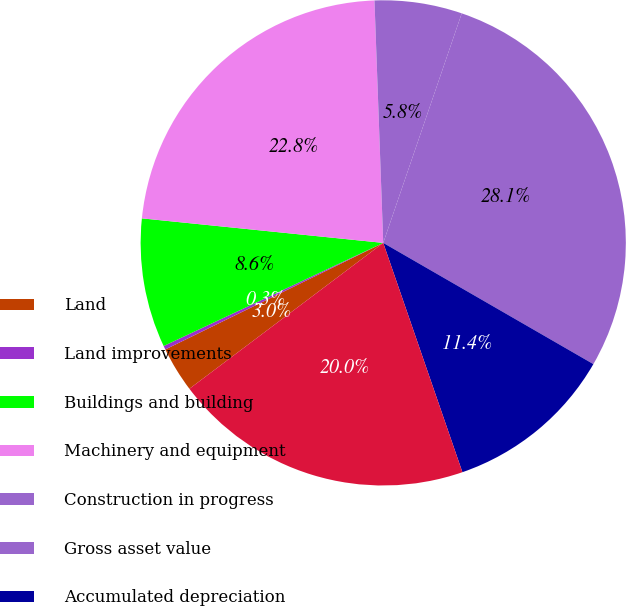Convert chart. <chart><loc_0><loc_0><loc_500><loc_500><pie_chart><fcel>Land<fcel>Land improvements<fcel>Buildings and building<fcel>Machinery and equipment<fcel>Construction in progress<fcel>Gross asset value<fcel>Accumulated depreciation<fcel>Total<nl><fcel>3.03%<fcel>0.25%<fcel>8.6%<fcel>22.81%<fcel>5.82%<fcel>28.08%<fcel>11.38%<fcel>20.02%<nl></chart> 